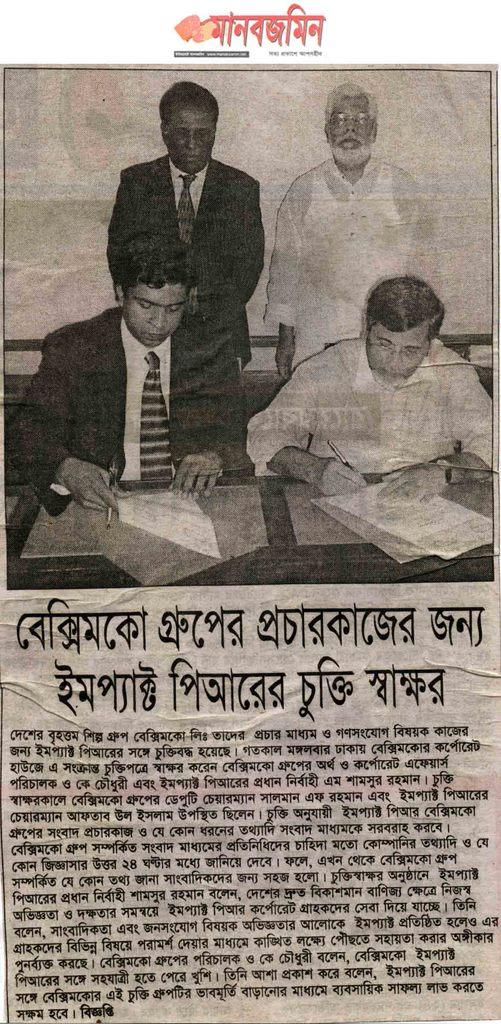What is present in the image? There is a paper in the image. What can be found on the paper? The paper contains text and an image of people. What type of rat can be seen in the image? There is no rat present in the image; it features a paper with text and an image of people. 